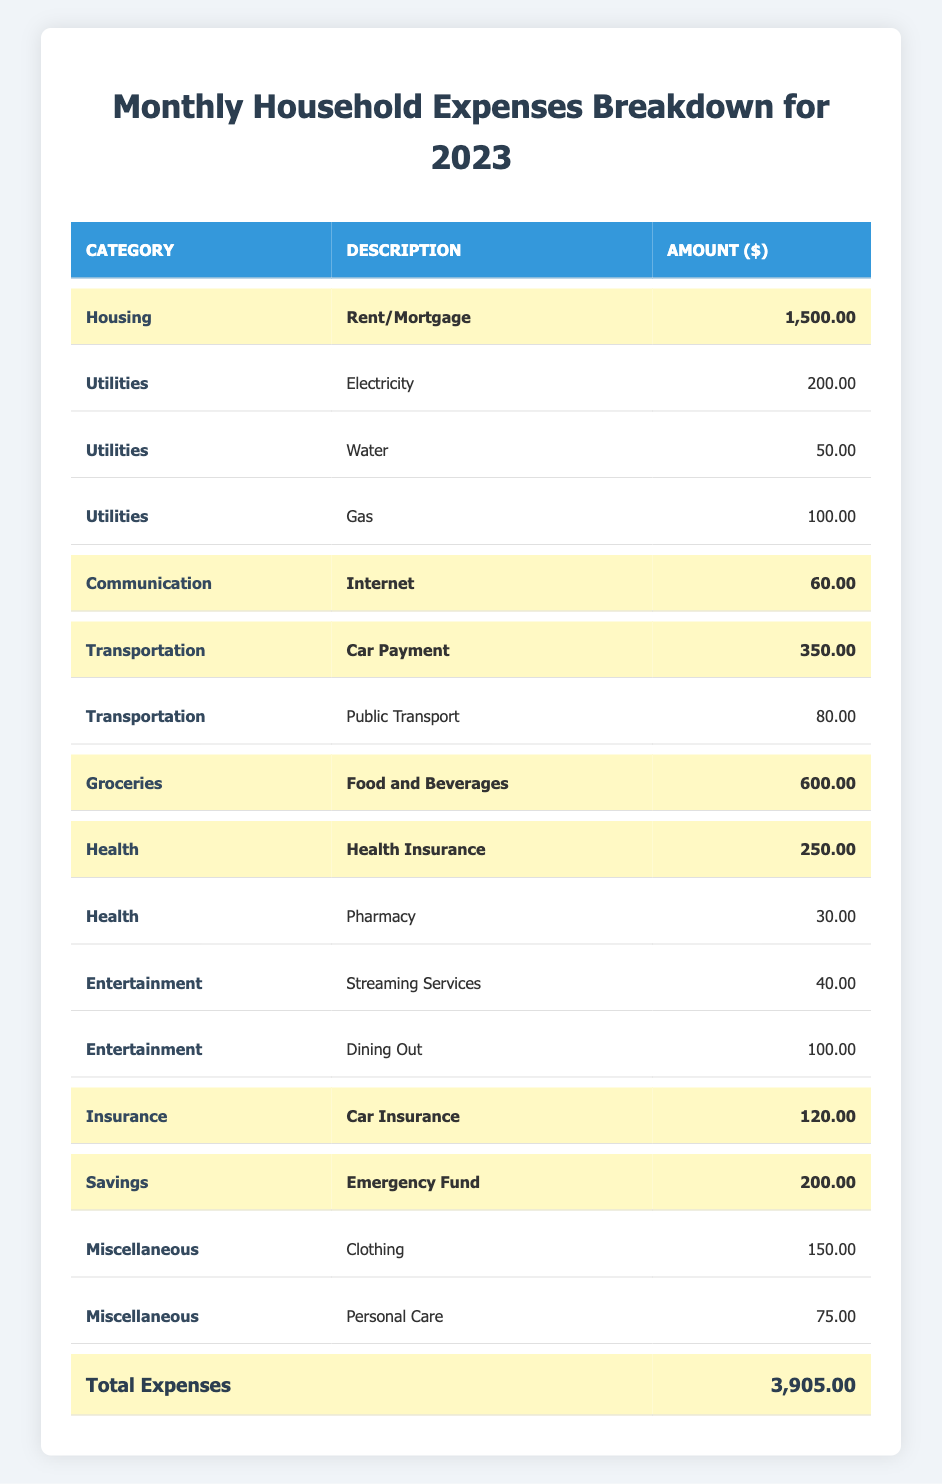What is the total amount spent on groceries? The table indicates that the amount spent on groceries, specifically "Food and Beverages," is $600.
Answer: 600 How much is spent on health insurance? The highlighted row for "Health Insurance" under the Health category shows an expense of $250.
Answer: 250 Is the total household expense over $4000? The highlighted total expense shows $3,905, which is less than $4,000.
Answer: No Which category has the highest expense? By examining the amounts, "Housing" (Rent/Mortgage) at $1,500 is the highest expense, as it is greater than all other individual categories.
Answer: Housing What is the combined amount spent on utilities? The utilities expenses (Electricity, Water, Gas) total ($200 + $50 + $100) = $350.
Answer: 350 What percentage of the total expenses is allocated to savings? The amount for "Emergency Fund" is $200. The total expenses are $3,905. The percentage is (200/3905) * 100 = 5.12%.
Answer: 5.12% How much more is spent on housing than on transportation? The amount for housing is $1,500, while the amount for transportation (Car Payment) is $350. The difference is $1,500 - $350 = $1,150.
Answer: 1150 Is the amount spent on entertainment less than the amount spent on utilities? The total entertainment expense (Streaming Services + Dining Out) is $40 + $100 = $140, while utilities total $350. Since $140 is less than $350, the statement is true.
Answer: Yes What are the total expenses for health-related categories? The health-related expenses are Health Insurance ($250) and Pharmacy ($30), totaling $250 + $30 = $280.
Answer: 280 If the internet cost increases by 50%, what would be the new amount? The current expense for the Internet is $60. A 50% increase is calculated as $60 * 0.5 = $30, so the new amount would be $60 + $30 = $90.
Answer: 90 